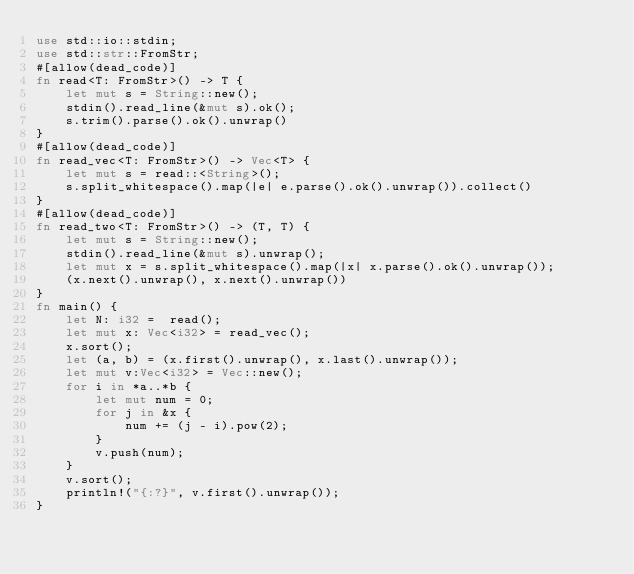<code> <loc_0><loc_0><loc_500><loc_500><_Rust_>use std::io::stdin;
use std::str::FromStr;
#[allow(dead_code)]
fn read<T: FromStr>() -> T {
    let mut s = String::new();
    stdin().read_line(&mut s).ok();
    s.trim().parse().ok().unwrap()
}
#[allow(dead_code)]
fn read_vec<T: FromStr>() -> Vec<T> {
    let mut s = read::<String>();
    s.split_whitespace().map(|e| e.parse().ok().unwrap()).collect()
}
#[allow(dead_code)]
fn read_two<T: FromStr>() -> (T, T) {
    let mut s = String::new();
    stdin().read_line(&mut s).unwrap();
    let mut x = s.split_whitespace().map(|x| x.parse().ok().unwrap());
    (x.next().unwrap(), x.next().unwrap())
}
fn main() {
    let N: i32 =  read();
    let mut x: Vec<i32> = read_vec();
    x.sort();
    let (a, b) = (x.first().unwrap(), x.last().unwrap());
    let mut v:Vec<i32> = Vec::new();
    for i in *a..*b {
        let mut num = 0;
        for j in &x {
            num += (j - i).pow(2);
        }
        v.push(num);
    }
    v.sort();
    println!("{:?}", v.first().unwrap());
}
</code> 